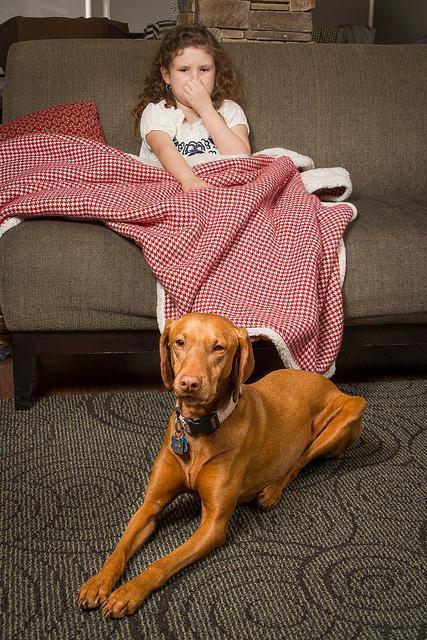How many of these bottles have yellow on the lid?
Give a very brief answer. 0. 